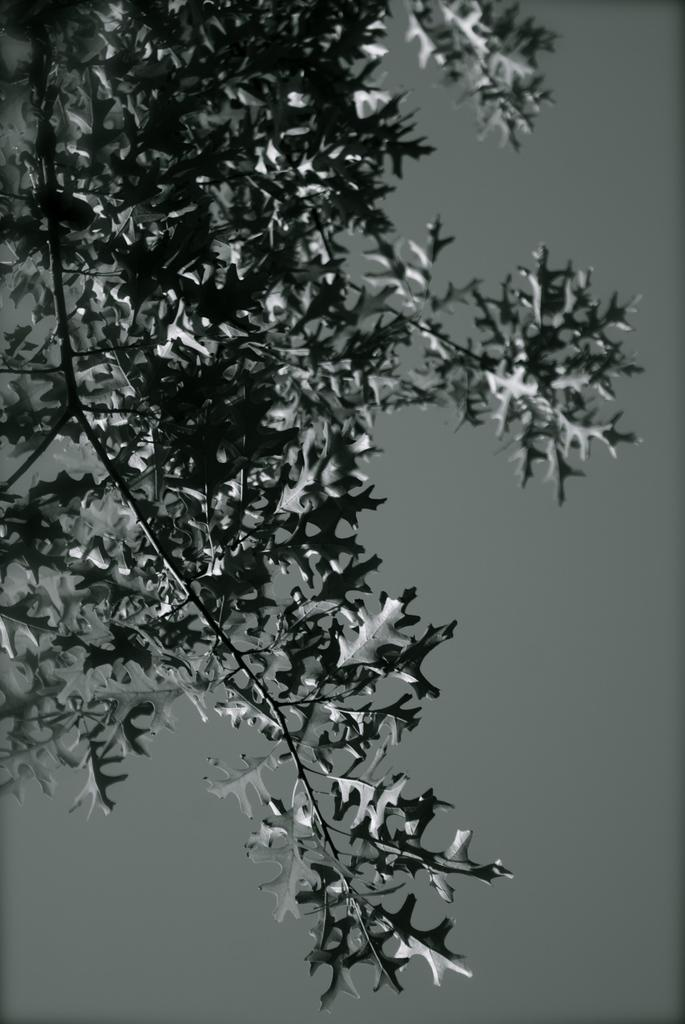What is the color scheme of the image? The image is black and white. What can be seen in the image besides the color scheme? There is a branch of a tree in the image. What is the branch of the tree like? The branch has many leaves. Can you tell me how many flowers are on the branch in the image? There are no flowers present on the branch in the image; it only has leaves. What type of vegetable is hanging from the branch in the image? There is no vegetable hanging from the branch in the image; it only has leaves. 